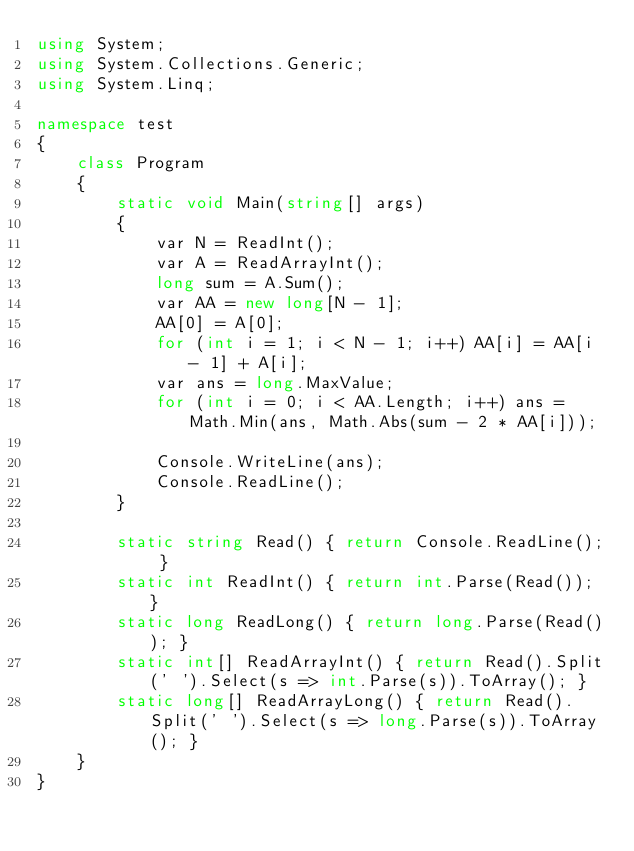Convert code to text. <code><loc_0><loc_0><loc_500><loc_500><_C#_>using System;
using System.Collections.Generic;
using System.Linq;

namespace test
{
    class Program
    {
        static void Main(string[] args)
        {
            var N = ReadInt();
            var A = ReadArrayInt();
            long sum = A.Sum();
            var AA = new long[N - 1];
            AA[0] = A[0];
            for (int i = 1; i < N - 1; i++) AA[i] = AA[i - 1] + A[i];
            var ans = long.MaxValue;
            for (int i = 0; i < AA.Length; i++) ans = Math.Min(ans, Math.Abs(sum - 2 * AA[i]));            

            Console.WriteLine(ans);
            Console.ReadLine();
        }

        static string Read() { return Console.ReadLine(); }
        static int ReadInt() { return int.Parse(Read()); }
        static long ReadLong() { return long.Parse(Read()); }
        static int[] ReadArrayInt() { return Read().Split(' ').Select(s => int.Parse(s)).ToArray(); }
        static long[] ReadArrayLong() { return Read().Split(' ').Select(s => long.Parse(s)).ToArray(); }
    }
}</code> 